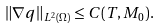Convert formula to latex. <formula><loc_0><loc_0><loc_500><loc_500>\| \nabla q \| _ { L ^ { 2 } ( \Omega ) } \leq C ( T , M _ { 0 } ) .</formula> 